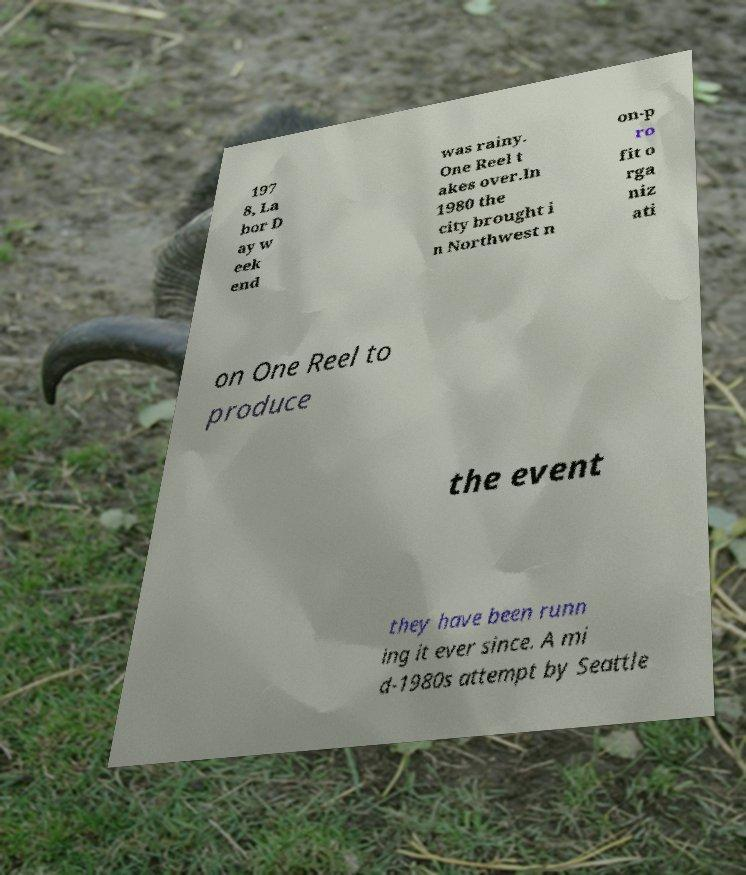Please identify and transcribe the text found in this image. 197 8, La bor D ay w eek end was rainy. One Reel t akes over.In 1980 the city brought i n Northwest n on-p ro fit o rga niz ati on One Reel to produce the event they have been runn ing it ever since. A mi d-1980s attempt by Seattle 